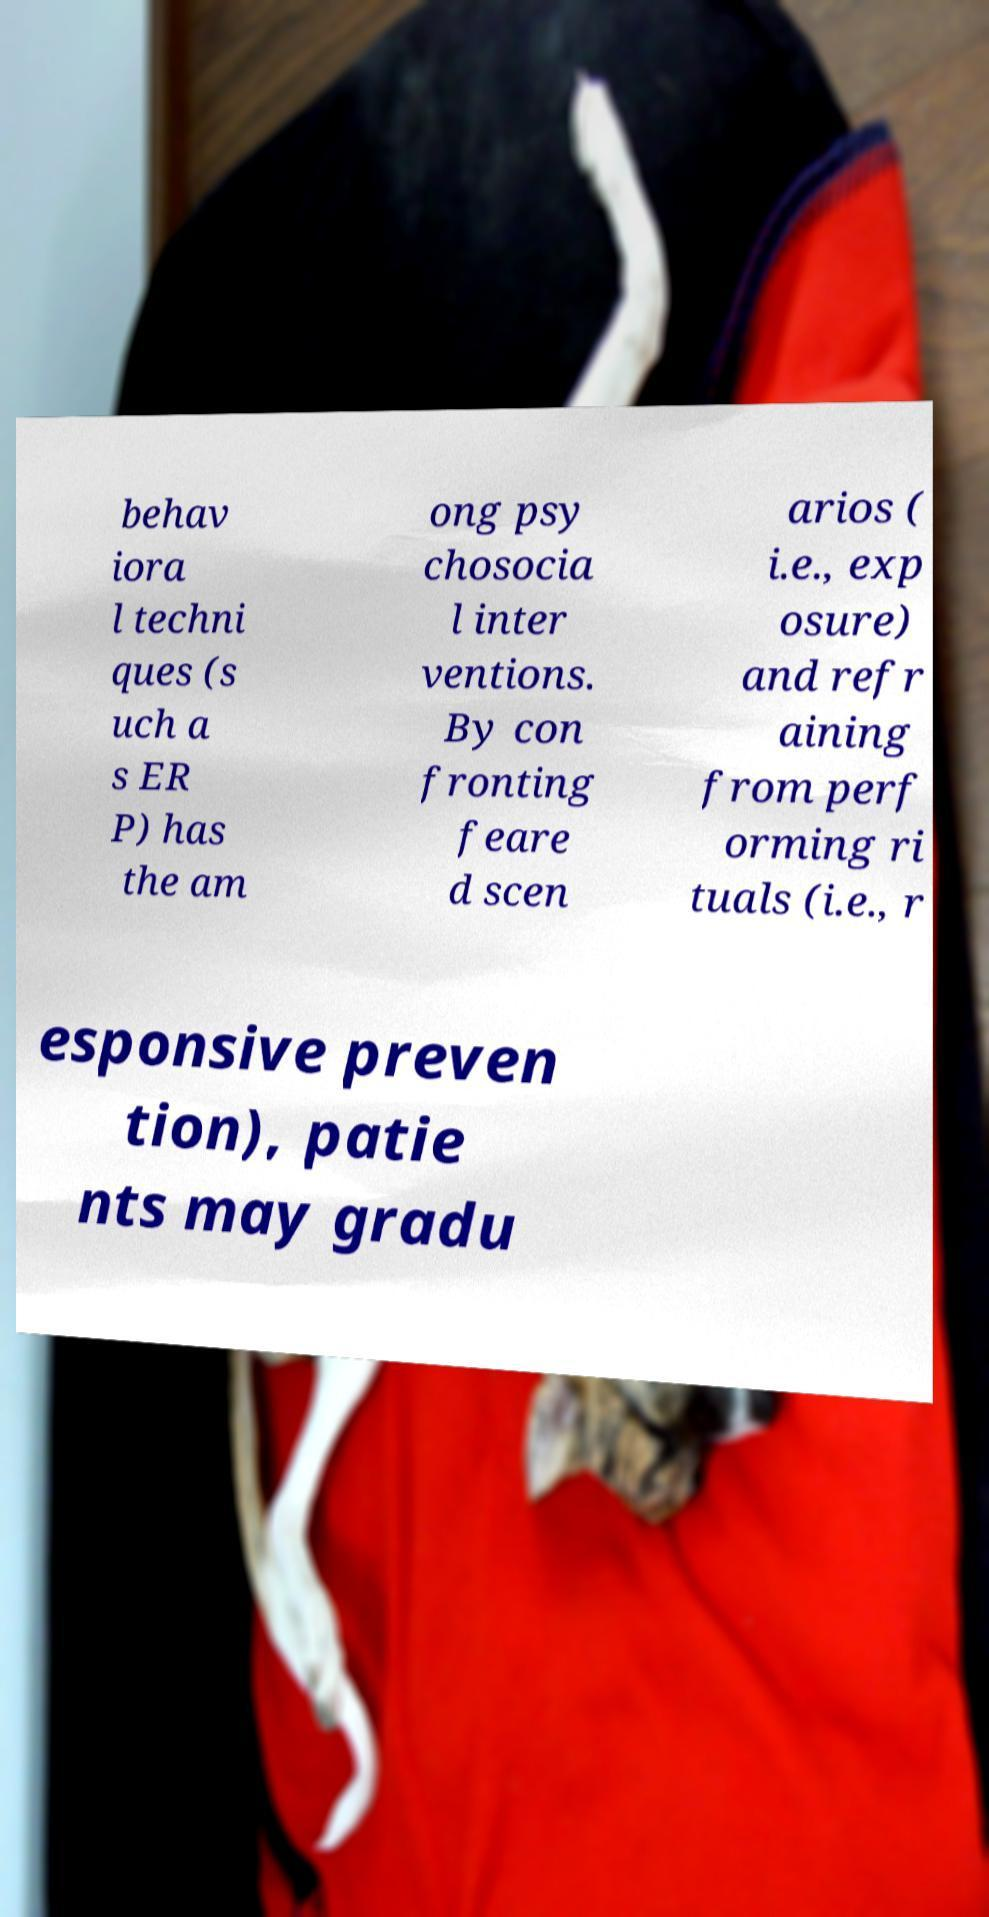Can you accurately transcribe the text from the provided image for me? behav iora l techni ques (s uch a s ER P) has the am ong psy chosocia l inter ventions. By con fronting feare d scen arios ( i.e., exp osure) and refr aining from perf orming ri tuals (i.e., r esponsive preven tion), patie nts may gradu 